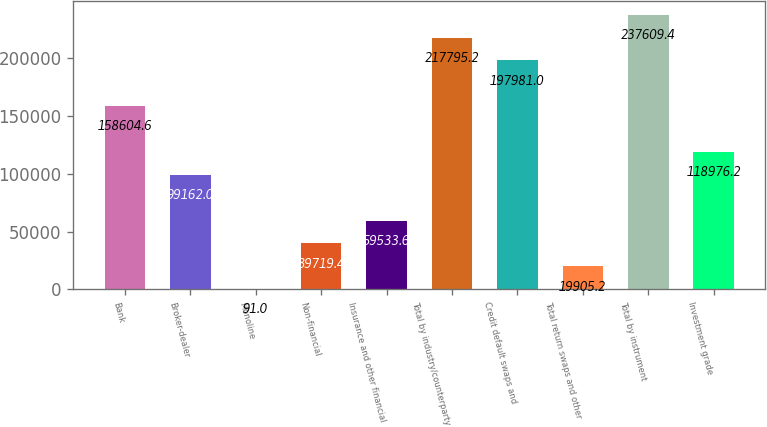<chart> <loc_0><loc_0><loc_500><loc_500><bar_chart><fcel>Bank<fcel>Broker-dealer<fcel>Monoline<fcel>Non-financial<fcel>Insurance and other financial<fcel>Total by industry/counterparty<fcel>Credit default swaps and<fcel>Total return swaps and other<fcel>Total by instrument<fcel>Investment grade<nl><fcel>158605<fcel>99162<fcel>91<fcel>39719.4<fcel>59533.6<fcel>217795<fcel>197981<fcel>19905.2<fcel>237609<fcel>118976<nl></chart> 